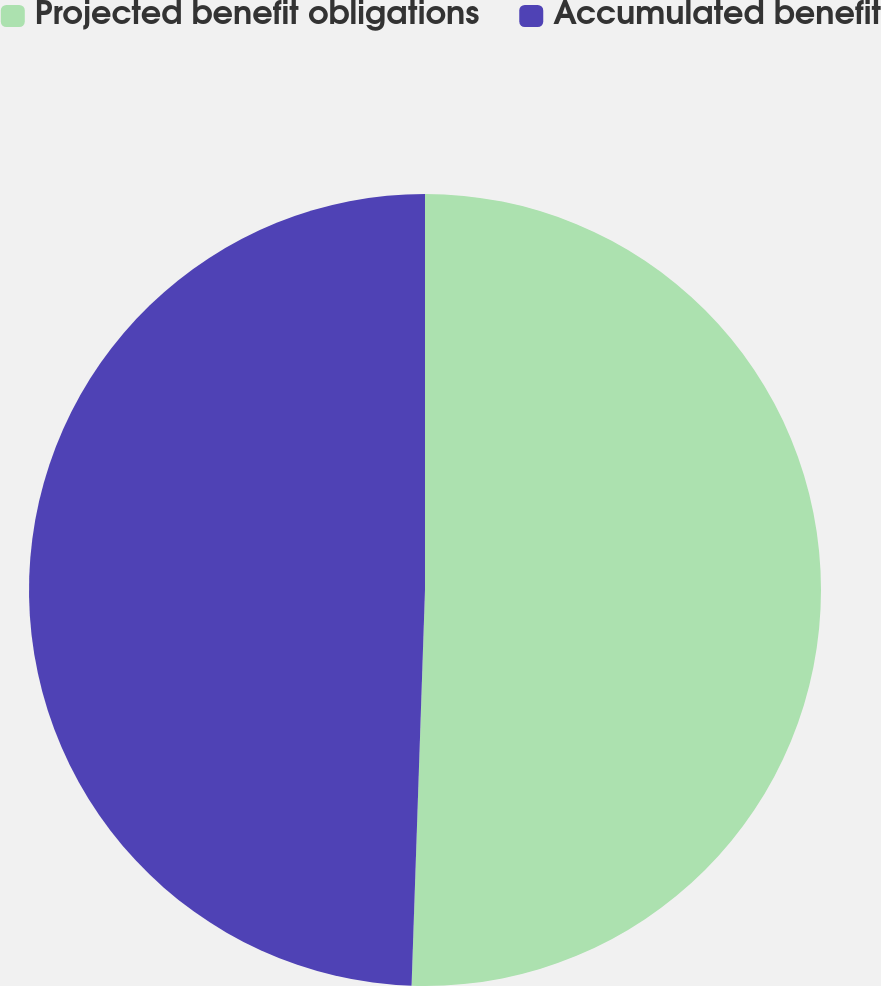<chart> <loc_0><loc_0><loc_500><loc_500><pie_chart><fcel>Projected benefit obligations<fcel>Accumulated benefit<nl><fcel>50.54%<fcel>49.46%<nl></chart> 